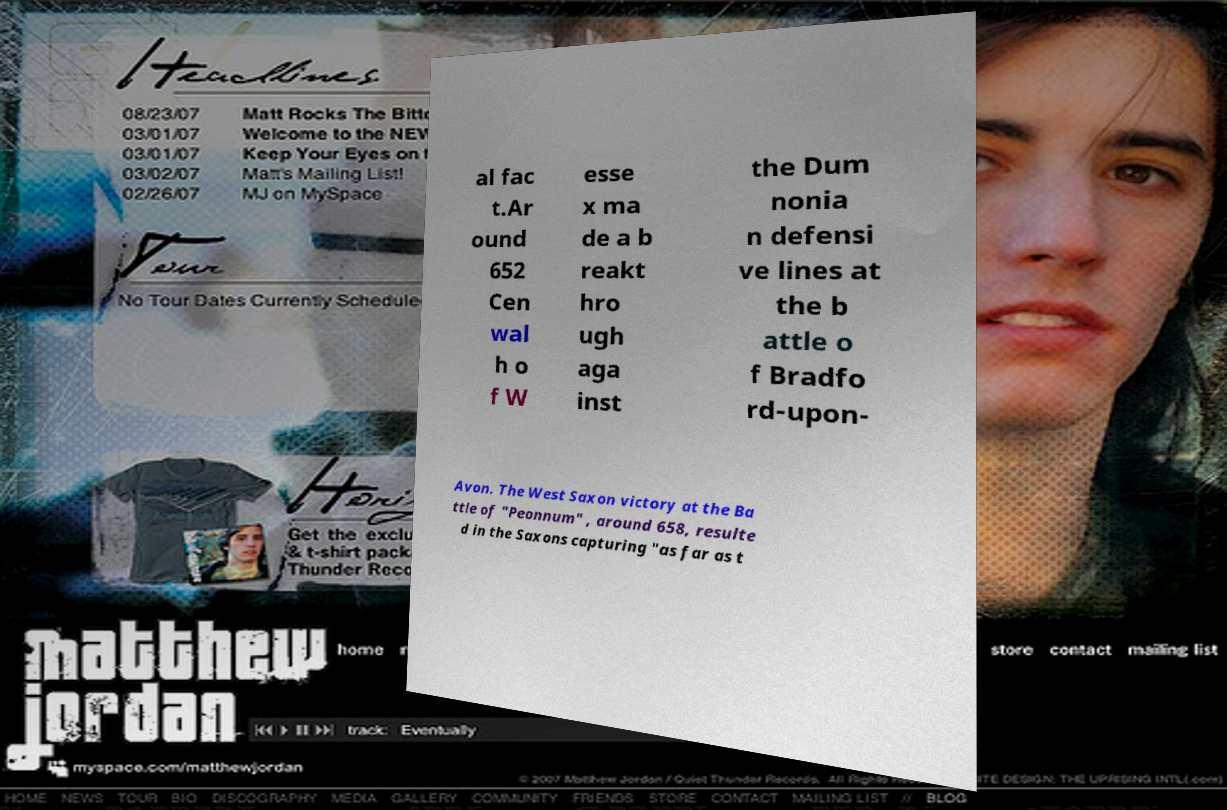For documentation purposes, I need the text within this image transcribed. Could you provide that? al fac t.Ar ound 652 Cen wal h o f W esse x ma de a b reakt hro ugh aga inst the Dum nonia n defensi ve lines at the b attle o f Bradfo rd-upon- Avon. The West Saxon victory at the Ba ttle of "Peonnum" , around 658, resulte d in the Saxons capturing "as far as t 